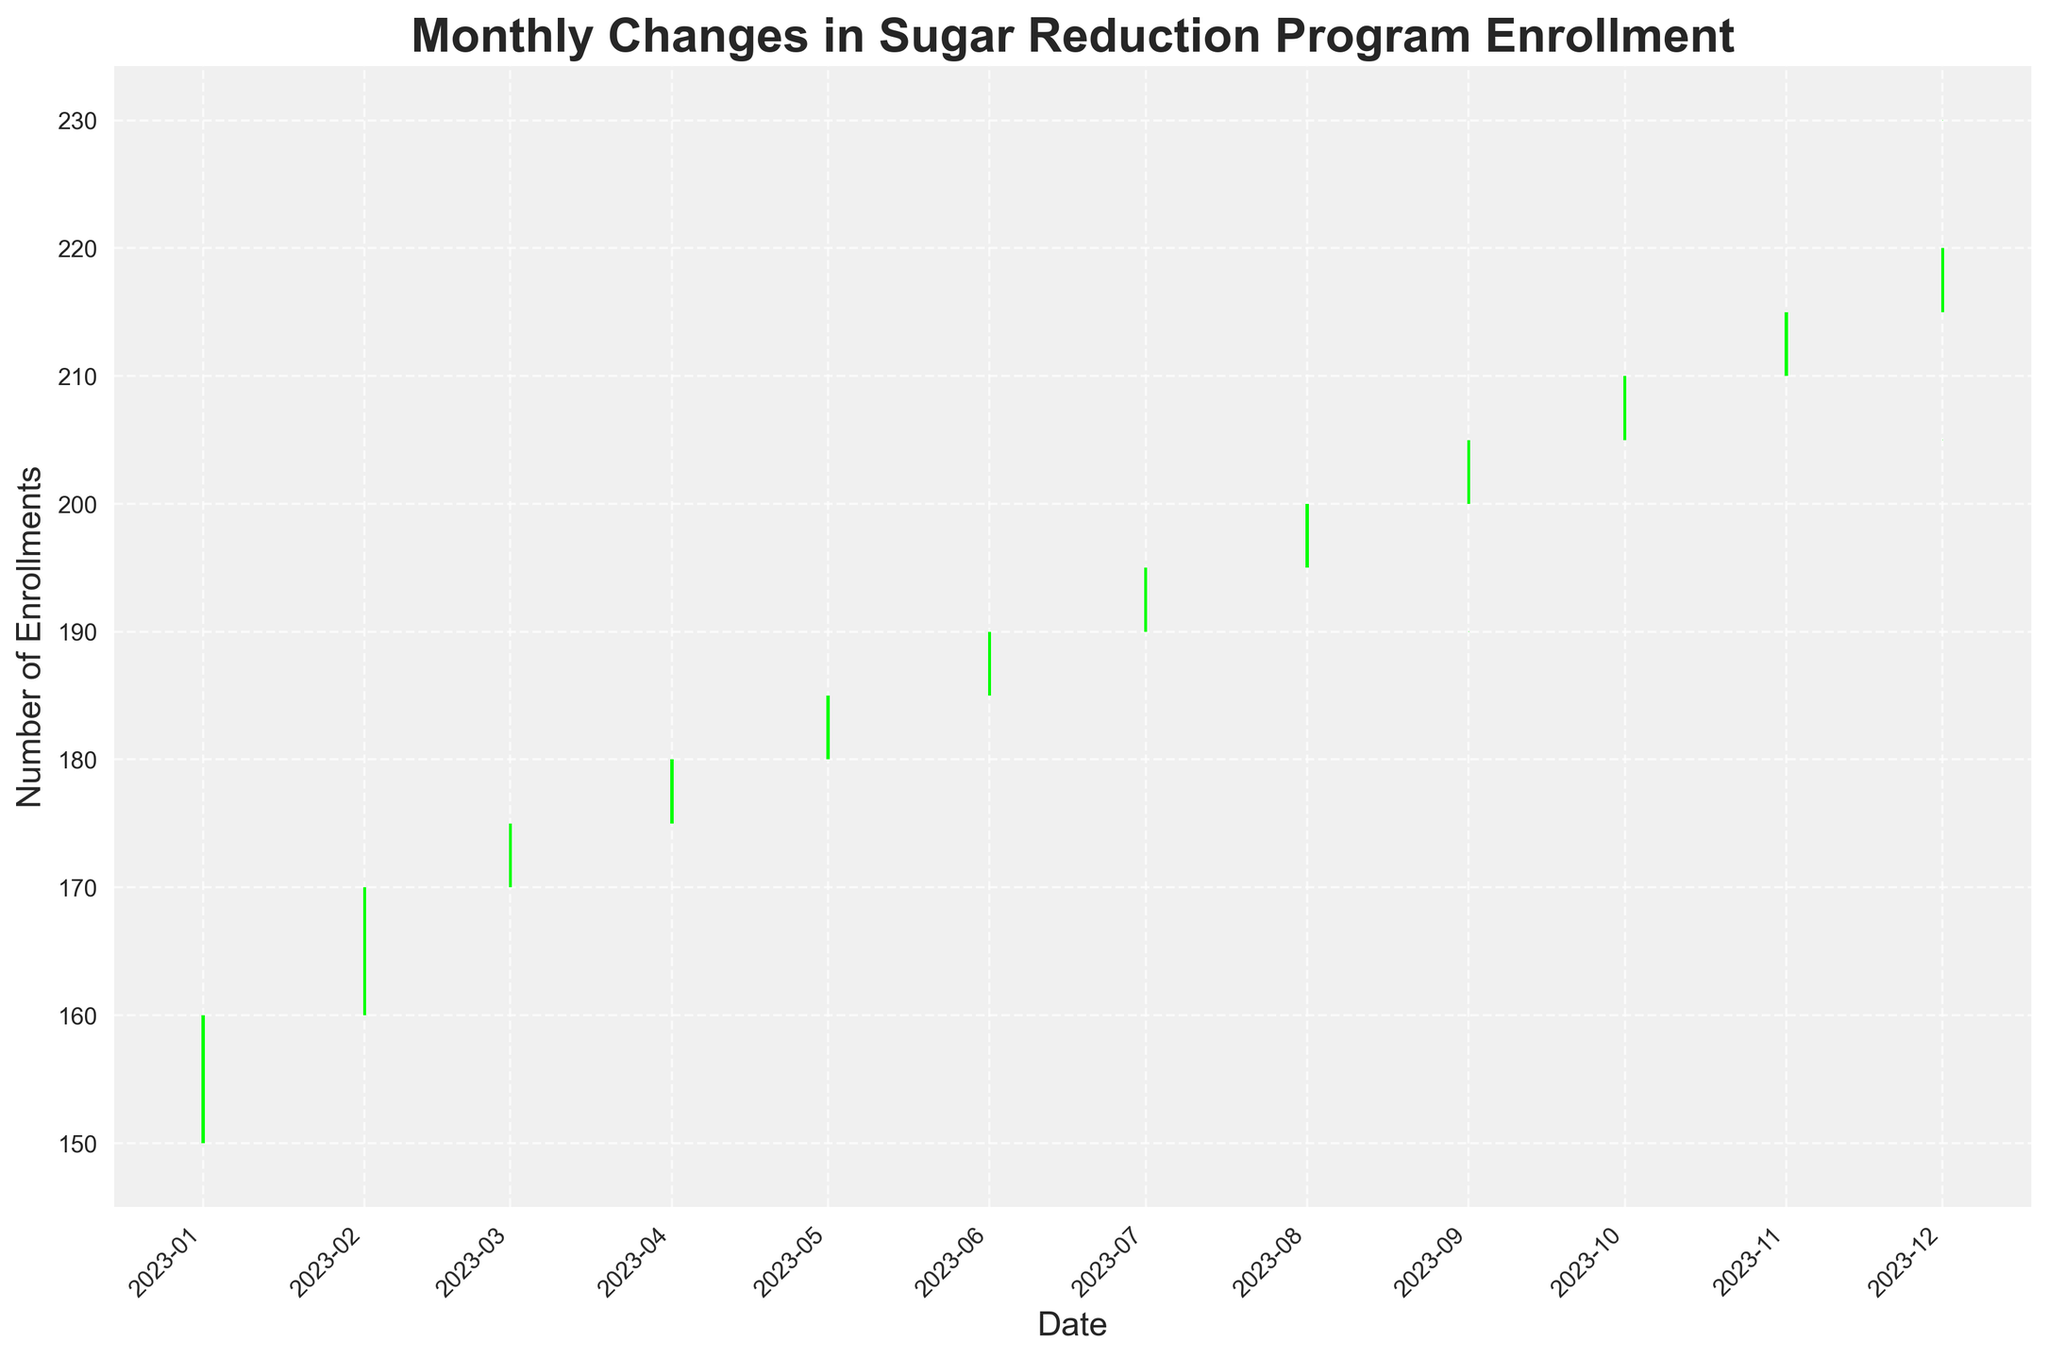What is the title of the figure? The title is found at the top of the figure and reads "Monthly Changes in Sugar Reduction Program Enrollment."
Answer: Monthly Changes in Sugar Reduction Program Enrollment Which month has the highest enrollment increase, based on the closing value? Look at the x-axis for the date and the highest closing value on the candlesticks. October 2023 has the highest closing value.
Answer: October 2023 How many months show an increase in program enrollment (green candlesticks)? Count the number of green candlesticks representing months where the closing value is higher than the opening value.
Answer: 12 What is the highest number of enrollments recorded in any month? The highest enrollment can be seen at the peak of the highest candlestick, corresponding to December 2023 with a high value of 230.
Answer: 230 In which month did the smallest range between high and low values occur? To find the smallest range, subtract the low value from the high value for each month and identify the smallest result. The smallest range is in January 2023 (175 - 145 = 30).
Answer: January 2023 By how much did the enrollment increase from September 2023 to October 2023? Subtract the closing value of September 2023 from the closing value of October 2023. October 2023: 210, September 2023: 205. Thus, 210 - 205 = 5.
Answer: 5 When did the program enrollment peak within a single month? The peak within a single month is identified by the highest "High" value seen on the candlesticks, which is 230 in December 2023.
Answer: December 2023 Which month had the largest number of enrollments dropped from its high value? Calculate the difference between the high value and closing value for each month and identify the largest difference. The largest drop of 20 occurred in December 2023 (230 - 220).
Answer: December 2023 